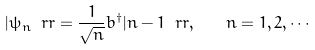<formula> <loc_0><loc_0><loc_500><loc_500>| \psi _ { n } \ r r = \frac { 1 } { \sqrt { n } } b ^ { \dagger } | n - 1 \ r r , \quad n = 1 , 2 , \cdots</formula> 